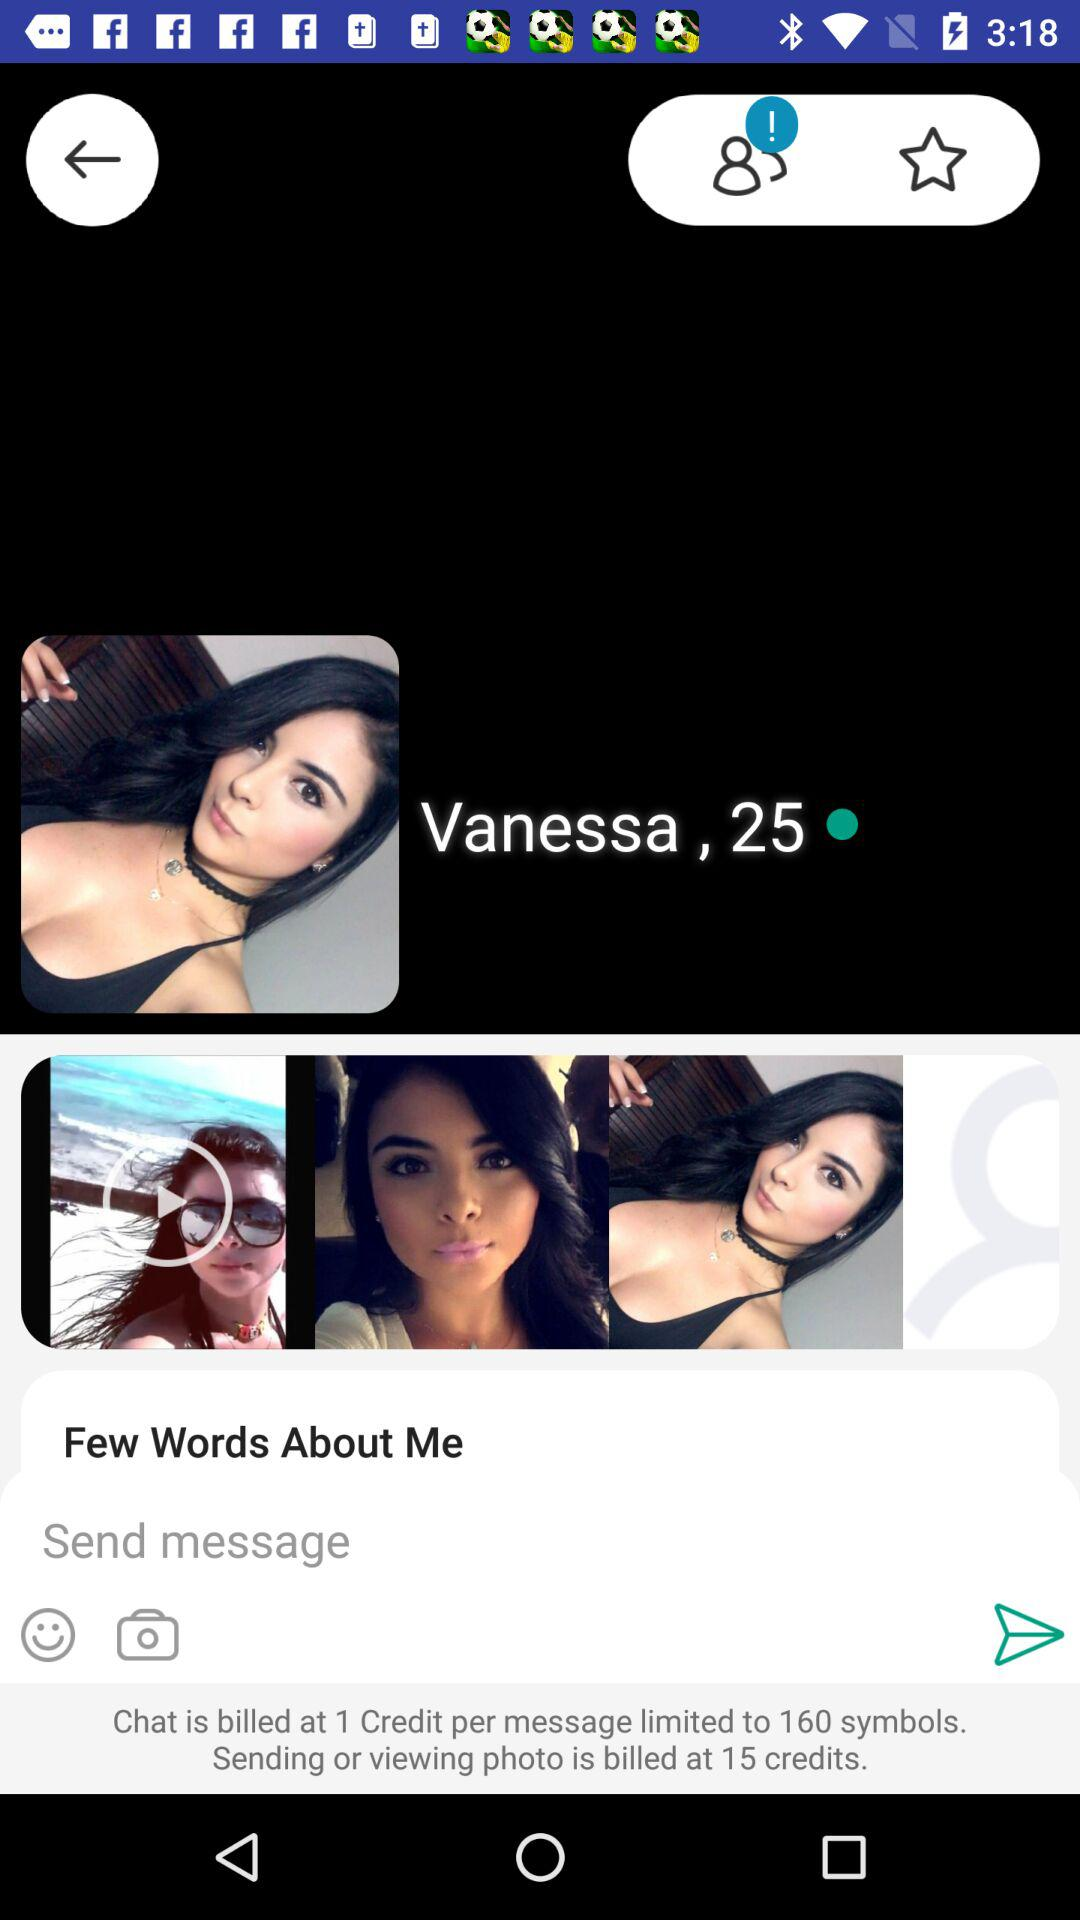How many credit is billed for sending and viewing the photo? There are 15 credits billed for sending and viewing the photo. 